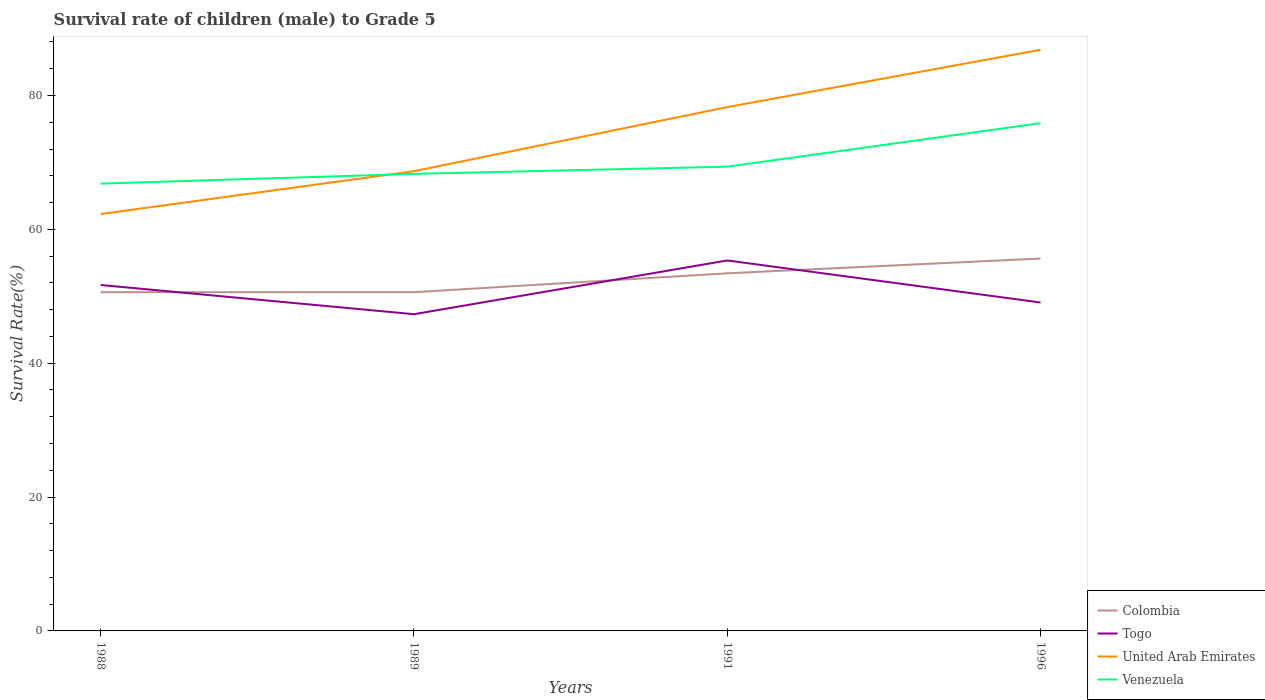Does the line corresponding to Colombia intersect with the line corresponding to Venezuela?
Give a very brief answer. No. Is the number of lines equal to the number of legend labels?
Ensure brevity in your answer.  Yes. Across all years, what is the maximum survival rate of male children to grade 5 in United Arab Emirates?
Provide a succinct answer. 62.29. In which year was the survival rate of male children to grade 5 in United Arab Emirates maximum?
Offer a terse response. 1988. What is the total survival rate of male children to grade 5 in United Arab Emirates in the graph?
Ensure brevity in your answer.  -18.14. What is the difference between the highest and the second highest survival rate of male children to grade 5 in Venezuela?
Your response must be concise. 9.03. Is the survival rate of male children to grade 5 in United Arab Emirates strictly greater than the survival rate of male children to grade 5 in Colombia over the years?
Offer a very short reply. No. How many years are there in the graph?
Offer a very short reply. 4. What is the difference between two consecutive major ticks on the Y-axis?
Ensure brevity in your answer.  20. Does the graph contain grids?
Your answer should be very brief. No. How many legend labels are there?
Give a very brief answer. 4. How are the legend labels stacked?
Give a very brief answer. Vertical. What is the title of the graph?
Your answer should be very brief. Survival rate of children (male) to Grade 5. What is the label or title of the Y-axis?
Offer a very short reply. Survival Rate(%). What is the Survival Rate(%) of Colombia in 1988?
Your response must be concise. 50.61. What is the Survival Rate(%) in Togo in 1988?
Provide a succinct answer. 51.68. What is the Survival Rate(%) of United Arab Emirates in 1988?
Ensure brevity in your answer.  62.29. What is the Survival Rate(%) in Venezuela in 1988?
Give a very brief answer. 66.83. What is the Survival Rate(%) of Colombia in 1989?
Give a very brief answer. 50.61. What is the Survival Rate(%) of Togo in 1989?
Keep it short and to the point. 47.32. What is the Survival Rate(%) in United Arab Emirates in 1989?
Provide a short and direct response. 68.68. What is the Survival Rate(%) of Venezuela in 1989?
Your response must be concise. 68.29. What is the Survival Rate(%) of Colombia in 1991?
Offer a terse response. 53.43. What is the Survival Rate(%) of Togo in 1991?
Offer a terse response. 55.35. What is the Survival Rate(%) of United Arab Emirates in 1991?
Offer a very short reply. 78.26. What is the Survival Rate(%) of Venezuela in 1991?
Offer a terse response. 69.36. What is the Survival Rate(%) of Colombia in 1996?
Offer a very short reply. 55.64. What is the Survival Rate(%) in Togo in 1996?
Your answer should be very brief. 49.07. What is the Survival Rate(%) in United Arab Emirates in 1996?
Your answer should be compact. 86.82. What is the Survival Rate(%) of Venezuela in 1996?
Offer a terse response. 75.86. Across all years, what is the maximum Survival Rate(%) in Colombia?
Ensure brevity in your answer.  55.64. Across all years, what is the maximum Survival Rate(%) of Togo?
Offer a very short reply. 55.35. Across all years, what is the maximum Survival Rate(%) of United Arab Emirates?
Give a very brief answer. 86.82. Across all years, what is the maximum Survival Rate(%) of Venezuela?
Your answer should be very brief. 75.86. Across all years, what is the minimum Survival Rate(%) of Colombia?
Ensure brevity in your answer.  50.61. Across all years, what is the minimum Survival Rate(%) in Togo?
Offer a terse response. 47.32. Across all years, what is the minimum Survival Rate(%) in United Arab Emirates?
Provide a succinct answer. 62.29. Across all years, what is the minimum Survival Rate(%) of Venezuela?
Offer a terse response. 66.83. What is the total Survival Rate(%) in Colombia in the graph?
Your answer should be very brief. 210.28. What is the total Survival Rate(%) in Togo in the graph?
Provide a short and direct response. 203.42. What is the total Survival Rate(%) in United Arab Emirates in the graph?
Offer a terse response. 296.05. What is the total Survival Rate(%) of Venezuela in the graph?
Give a very brief answer. 280.33. What is the difference between the Survival Rate(%) of Colombia in 1988 and that in 1989?
Your answer should be very brief. -0. What is the difference between the Survival Rate(%) in Togo in 1988 and that in 1989?
Your answer should be very brief. 4.36. What is the difference between the Survival Rate(%) in United Arab Emirates in 1988 and that in 1989?
Offer a very short reply. -6.4. What is the difference between the Survival Rate(%) in Venezuela in 1988 and that in 1989?
Your response must be concise. -1.46. What is the difference between the Survival Rate(%) in Colombia in 1988 and that in 1991?
Offer a very short reply. -2.82. What is the difference between the Survival Rate(%) of Togo in 1988 and that in 1991?
Offer a very short reply. -3.67. What is the difference between the Survival Rate(%) in United Arab Emirates in 1988 and that in 1991?
Your response must be concise. -15.98. What is the difference between the Survival Rate(%) of Venezuela in 1988 and that in 1991?
Your answer should be very brief. -2.53. What is the difference between the Survival Rate(%) of Colombia in 1988 and that in 1996?
Your response must be concise. -5.03. What is the difference between the Survival Rate(%) in Togo in 1988 and that in 1996?
Provide a short and direct response. 2.61. What is the difference between the Survival Rate(%) in United Arab Emirates in 1988 and that in 1996?
Offer a terse response. -24.54. What is the difference between the Survival Rate(%) of Venezuela in 1988 and that in 1996?
Make the answer very short. -9.03. What is the difference between the Survival Rate(%) of Colombia in 1989 and that in 1991?
Keep it short and to the point. -2.82. What is the difference between the Survival Rate(%) of Togo in 1989 and that in 1991?
Provide a short and direct response. -8.03. What is the difference between the Survival Rate(%) of United Arab Emirates in 1989 and that in 1991?
Offer a very short reply. -9.58. What is the difference between the Survival Rate(%) in Venezuela in 1989 and that in 1991?
Provide a short and direct response. -1.07. What is the difference between the Survival Rate(%) in Colombia in 1989 and that in 1996?
Offer a terse response. -5.03. What is the difference between the Survival Rate(%) in Togo in 1989 and that in 1996?
Provide a short and direct response. -1.75. What is the difference between the Survival Rate(%) of United Arab Emirates in 1989 and that in 1996?
Keep it short and to the point. -18.14. What is the difference between the Survival Rate(%) in Venezuela in 1989 and that in 1996?
Your answer should be very brief. -7.57. What is the difference between the Survival Rate(%) in Colombia in 1991 and that in 1996?
Provide a short and direct response. -2.21. What is the difference between the Survival Rate(%) of Togo in 1991 and that in 1996?
Keep it short and to the point. 6.28. What is the difference between the Survival Rate(%) of United Arab Emirates in 1991 and that in 1996?
Provide a short and direct response. -8.56. What is the difference between the Survival Rate(%) of Venezuela in 1991 and that in 1996?
Your answer should be very brief. -6.5. What is the difference between the Survival Rate(%) in Colombia in 1988 and the Survival Rate(%) in Togo in 1989?
Offer a very short reply. 3.29. What is the difference between the Survival Rate(%) of Colombia in 1988 and the Survival Rate(%) of United Arab Emirates in 1989?
Your answer should be very brief. -18.08. What is the difference between the Survival Rate(%) in Colombia in 1988 and the Survival Rate(%) in Venezuela in 1989?
Your response must be concise. -17.68. What is the difference between the Survival Rate(%) of Togo in 1988 and the Survival Rate(%) of United Arab Emirates in 1989?
Provide a short and direct response. -17. What is the difference between the Survival Rate(%) in Togo in 1988 and the Survival Rate(%) in Venezuela in 1989?
Provide a short and direct response. -16.61. What is the difference between the Survival Rate(%) in United Arab Emirates in 1988 and the Survival Rate(%) in Venezuela in 1989?
Your response must be concise. -6. What is the difference between the Survival Rate(%) in Colombia in 1988 and the Survival Rate(%) in Togo in 1991?
Provide a succinct answer. -4.74. What is the difference between the Survival Rate(%) of Colombia in 1988 and the Survival Rate(%) of United Arab Emirates in 1991?
Your response must be concise. -27.65. What is the difference between the Survival Rate(%) of Colombia in 1988 and the Survival Rate(%) of Venezuela in 1991?
Your response must be concise. -18.75. What is the difference between the Survival Rate(%) in Togo in 1988 and the Survival Rate(%) in United Arab Emirates in 1991?
Your response must be concise. -26.58. What is the difference between the Survival Rate(%) in Togo in 1988 and the Survival Rate(%) in Venezuela in 1991?
Your answer should be compact. -17.68. What is the difference between the Survival Rate(%) of United Arab Emirates in 1988 and the Survival Rate(%) of Venezuela in 1991?
Your answer should be compact. -7.07. What is the difference between the Survival Rate(%) in Colombia in 1988 and the Survival Rate(%) in Togo in 1996?
Offer a terse response. 1.54. What is the difference between the Survival Rate(%) of Colombia in 1988 and the Survival Rate(%) of United Arab Emirates in 1996?
Provide a short and direct response. -36.22. What is the difference between the Survival Rate(%) in Colombia in 1988 and the Survival Rate(%) in Venezuela in 1996?
Provide a succinct answer. -25.25. What is the difference between the Survival Rate(%) in Togo in 1988 and the Survival Rate(%) in United Arab Emirates in 1996?
Ensure brevity in your answer.  -35.14. What is the difference between the Survival Rate(%) of Togo in 1988 and the Survival Rate(%) of Venezuela in 1996?
Ensure brevity in your answer.  -24.18. What is the difference between the Survival Rate(%) in United Arab Emirates in 1988 and the Survival Rate(%) in Venezuela in 1996?
Your response must be concise. -13.57. What is the difference between the Survival Rate(%) of Colombia in 1989 and the Survival Rate(%) of Togo in 1991?
Give a very brief answer. -4.74. What is the difference between the Survival Rate(%) of Colombia in 1989 and the Survival Rate(%) of United Arab Emirates in 1991?
Provide a succinct answer. -27.65. What is the difference between the Survival Rate(%) of Colombia in 1989 and the Survival Rate(%) of Venezuela in 1991?
Give a very brief answer. -18.75. What is the difference between the Survival Rate(%) of Togo in 1989 and the Survival Rate(%) of United Arab Emirates in 1991?
Offer a terse response. -30.94. What is the difference between the Survival Rate(%) of Togo in 1989 and the Survival Rate(%) of Venezuela in 1991?
Offer a terse response. -22.04. What is the difference between the Survival Rate(%) in United Arab Emirates in 1989 and the Survival Rate(%) in Venezuela in 1991?
Offer a terse response. -0.67. What is the difference between the Survival Rate(%) of Colombia in 1989 and the Survival Rate(%) of Togo in 1996?
Provide a succinct answer. 1.54. What is the difference between the Survival Rate(%) of Colombia in 1989 and the Survival Rate(%) of United Arab Emirates in 1996?
Offer a terse response. -36.21. What is the difference between the Survival Rate(%) of Colombia in 1989 and the Survival Rate(%) of Venezuela in 1996?
Offer a very short reply. -25.25. What is the difference between the Survival Rate(%) in Togo in 1989 and the Survival Rate(%) in United Arab Emirates in 1996?
Provide a short and direct response. -39.5. What is the difference between the Survival Rate(%) in Togo in 1989 and the Survival Rate(%) in Venezuela in 1996?
Ensure brevity in your answer.  -28.54. What is the difference between the Survival Rate(%) in United Arab Emirates in 1989 and the Survival Rate(%) in Venezuela in 1996?
Your answer should be compact. -7.18. What is the difference between the Survival Rate(%) in Colombia in 1991 and the Survival Rate(%) in Togo in 1996?
Give a very brief answer. 4.36. What is the difference between the Survival Rate(%) in Colombia in 1991 and the Survival Rate(%) in United Arab Emirates in 1996?
Your response must be concise. -33.39. What is the difference between the Survival Rate(%) in Colombia in 1991 and the Survival Rate(%) in Venezuela in 1996?
Offer a very short reply. -22.43. What is the difference between the Survival Rate(%) in Togo in 1991 and the Survival Rate(%) in United Arab Emirates in 1996?
Keep it short and to the point. -31.47. What is the difference between the Survival Rate(%) of Togo in 1991 and the Survival Rate(%) of Venezuela in 1996?
Provide a short and direct response. -20.51. What is the difference between the Survival Rate(%) in United Arab Emirates in 1991 and the Survival Rate(%) in Venezuela in 1996?
Keep it short and to the point. 2.4. What is the average Survival Rate(%) in Colombia per year?
Offer a very short reply. 52.57. What is the average Survival Rate(%) in Togo per year?
Your response must be concise. 50.85. What is the average Survival Rate(%) in United Arab Emirates per year?
Ensure brevity in your answer.  74.01. What is the average Survival Rate(%) of Venezuela per year?
Provide a succinct answer. 70.08. In the year 1988, what is the difference between the Survival Rate(%) in Colombia and Survival Rate(%) in Togo?
Offer a terse response. -1.07. In the year 1988, what is the difference between the Survival Rate(%) of Colombia and Survival Rate(%) of United Arab Emirates?
Your answer should be compact. -11.68. In the year 1988, what is the difference between the Survival Rate(%) of Colombia and Survival Rate(%) of Venezuela?
Your answer should be compact. -16.22. In the year 1988, what is the difference between the Survival Rate(%) of Togo and Survival Rate(%) of United Arab Emirates?
Offer a very short reply. -10.6. In the year 1988, what is the difference between the Survival Rate(%) in Togo and Survival Rate(%) in Venezuela?
Make the answer very short. -15.15. In the year 1988, what is the difference between the Survival Rate(%) of United Arab Emirates and Survival Rate(%) of Venezuela?
Give a very brief answer. -4.54. In the year 1989, what is the difference between the Survival Rate(%) of Colombia and Survival Rate(%) of Togo?
Give a very brief answer. 3.29. In the year 1989, what is the difference between the Survival Rate(%) in Colombia and Survival Rate(%) in United Arab Emirates?
Make the answer very short. -18.08. In the year 1989, what is the difference between the Survival Rate(%) of Colombia and Survival Rate(%) of Venezuela?
Keep it short and to the point. -17.68. In the year 1989, what is the difference between the Survival Rate(%) of Togo and Survival Rate(%) of United Arab Emirates?
Give a very brief answer. -21.36. In the year 1989, what is the difference between the Survival Rate(%) of Togo and Survival Rate(%) of Venezuela?
Offer a terse response. -20.97. In the year 1989, what is the difference between the Survival Rate(%) of United Arab Emirates and Survival Rate(%) of Venezuela?
Offer a terse response. 0.4. In the year 1991, what is the difference between the Survival Rate(%) of Colombia and Survival Rate(%) of Togo?
Offer a terse response. -1.92. In the year 1991, what is the difference between the Survival Rate(%) of Colombia and Survival Rate(%) of United Arab Emirates?
Provide a short and direct response. -24.83. In the year 1991, what is the difference between the Survival Rate(%) in Colombia and Survival Rate(%) in Venezuela?
Give a very brief answer. -15.93. In the year 1991, what is the difference between the Survival Rate(%) of Togo and Survival Rate(%) of United Arab Emirates?
Ensure brevity in your answer.  -22.91. In the year 1991, what is the difference between the Survival Rate(%) in Togo and Survival Rate(%) in Venezuela?
Your answer should be compact. -14.01. In the year 1991, what is the difference between the Survival Rate(%) in United Arab Emirates and Survival Rate(%) in Venezuela?
Your response must be concise. 8.9. In the year 1996, what is the difference between the Survival Rate(%) in Colombia and Survival Rate(%) in Togo?
Make the answer very short. 6.57. In the year 1996, what is the difference between the Survival Rate(%) of Colombia and Survival Rate(%) of United Arab Emirates?
Your response must be concise. -31.19. In the year 1996, what is the difference between the Survival Rate(%) of Colombia and Survival Rate(%) of Venezuela?
Offer a terse response. -20.22. In the year 1996, what is the difference between the Survival Rate(%) in Togo and Survival Rate(%) in United Arab Emirates?
Your answer should be very brief. -37.75. In the year 1996, what is the difference between the Survival Rate(%) in Togo and Survival Rate(%) in Venezuela?
Ensure brevity in your answer.  -26.79. In the year 1996, what is the difference between the Survival Rate(%) in United Arab Emirates and Survival Rate(%) in Venezuela?
Your answer should be very brief. 10.96. What is the ratio of the Survival Rate(%) in Colombia in 1988 to that in 1989?
Your answer should be compact. 1. What is the ratio of the Survival Rate(%) in Togo in 1988 to that in 1989?
Ensure brevity in your answer.  1.09. What is the ratio of the Survival Rate(%) of United Arab Emirates in 1988 to that in 1989?
Give a very brief answer. 0.91. What is the ratio of the Survival Rate(%) of Venezuela in 1988 to that in 1989?
Offer a terse response. 0.98. What is the ratio of the Survival Rate(%) of Colombia in 1988 to that in 1991?
Your answer should be compact. 0.95. What is the ratio of the Survival Rate(%) of Togo in 1988 to that in 1991?
Your response must be concise. 0.93. What is the ratio of the Survival Rate(%) of United Arab Emirates in 1988 to that in 1991?
Your response must be concise. 0.8. What is the ratio of the Survival Rate(%) in Venezuela in 1988 to that in 1991?
Provide a succinct answer. 0.96. What is the ratio of the Survival Rate(%) of Colombia in 1988 to that in 1996?
Make the answer very short. 0.91. What is the ratio of the Survival Rate(%) in Togo in 1988 to that in 1996?
Ensure brevity in your answer.  1.05. What is the ratio of the Survival Rate(%) in United Arab Emirates in 1988 to that in 1996?
Give a very brief answer. 0.72. What is the ratio of the Survival Rate(%) in Venezuela in 1988 to that in 1996?
Your response must be concise. 0.88. What is the ratio of the Survival Rate(%) of Colombia in 1989 to that in 1991?
Give a very brief answer. 0.95. What is the ratio of the Survival Rate(%) in Togo in 1989 to that in 1991?
Your answer should be compact. 0.85. What is the ratio of the Survival Rate(%) in United Arab Emirates in 1989 to that in 1991?
Offer a very short reply. 0.88. What is the ratio of the Survival Rate(%) of Venezuela in 1989 to that in 1991?
Make the answer very short. 0.98. What is the ratio of the Survival Rate(%) of Colombia in 1989 to that in 1996?
Keep it short and to the point. 0.91. What is the ratio of the Survival Rate(%) of Togo in 1989 to that in 1996?
Make the answer very short. 0.96. What is the ratio of the Survival Rate(%) of United Arab Emirates in 1989 to that in 1996?
Offer a very short reply. 0.79. What is the ratio of the Survival Rate(%) in Venezuela in 1989 to that in 1996?
Offer a very short reply. 0.9. What is the ratio of the Survival Rate(%) in Colombia in 1991 to that in 1996?
Provide a succinct answer. 0.96. What is the ratio of the Survival Rate(%) in Togo in 1991 to that in 1996?
Offer a terse response. 1.13. What is the ratio of the Survival Rate(%) of United Arab Emirates in 1991 to that in 1996?
Offer a very short reply. 0.9. What is the ratio of the Survival Rate(%) in Venezuela in 1991 to that in 1996?
Offer a very short reply. 0.91. What is the difference between the highest and the second highest Survival Rate(%) in Colombia?
Offer a very short reply. 2.21. What is the difference between the highest and the second highest Survival Rate(%) in Togo?
Your answer should be very brief. 3.67. What is the difference between the highest and the second highest Survival Rate(%) of United Arab Emirates?
Your answer should be very brief. 8.56. What is the difference between the highest and the second highest Survival Rate(%) in Venezuela?
Provide a short and direct response. 6.5. What is the difference between the highest and the lowest Survival Rate(%) in Colombia?
Give a very brief answer. 5.03. What is the difference between the highest and the lowest Survival Rate(%) of Togo?
Provide a succinct answer. 8.03. What is the difference between the highest and the lowest Survival Rate(%) of United Arab Emirates?
Your answer should be very brief. 24.54. What is the difference between the highest and the lowest Survival Rate(%) of Venezuela?
Provide a succinct answer. 9.03. 